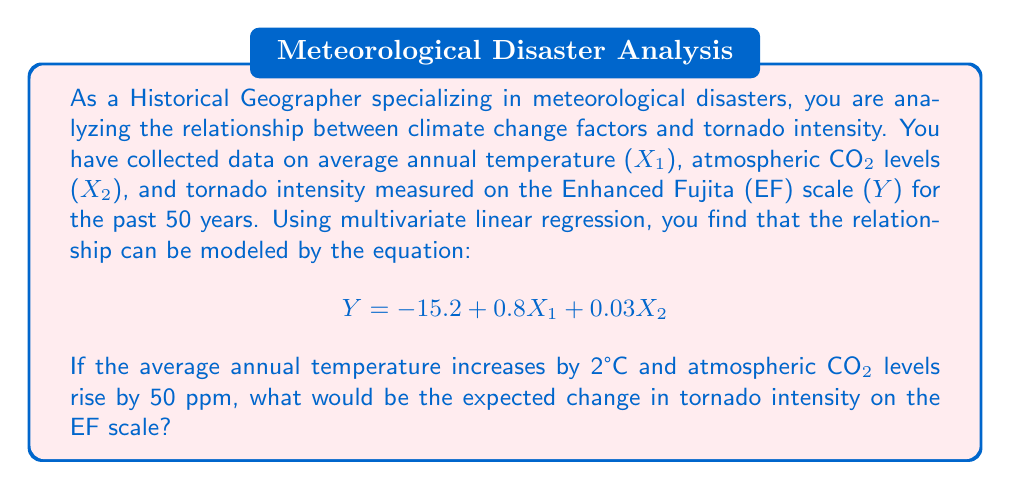Could you help me with this problem? To solve this problem, we'll follow these steps:

1. Identify the given information:
   - Regression equation: $Y = -15.2 + 0.8X_1 + 0.03X_2$
   - $X_1$: Average annual temperature
   - $X_2$: Atmospheric CO₂ levels
   - $Y$: Tornado intensity (EF scale)

2. Determine the changes in variables:
   - Change in temperature (ΔX₁) = 2°C
   - Change in CO₂ levels (ΔX₂) = 50 ppm

3. Calculate the change in Y using the partial derivatives:
   - $\frac{\partial Y}{\partial X_1} = 0.8$
   - $\frac{\partial Y}{\partial X_2} = 0.03$

4. Apply the changes to the partial derivatives:
   $$\Delta Y = \frac{\partial Y}{\partial X_1} \cdot \Delta X_1 + \frac{\partial Y}{\partial X_2} \cdot \Delta X_2$$
   $$\Delta Y = 0.8 \cdot 2 + 0.03 \cdot 50$$
   $$\Delta Y = 1.6 + 1.5$$
   $$\Delta Y = 3.1$$

5. Interpret the result:
   The expected change in tornado intensity on the EF scale would be an increase of 3.1 units.
Answer: 3.1 units increase on the EF scale 